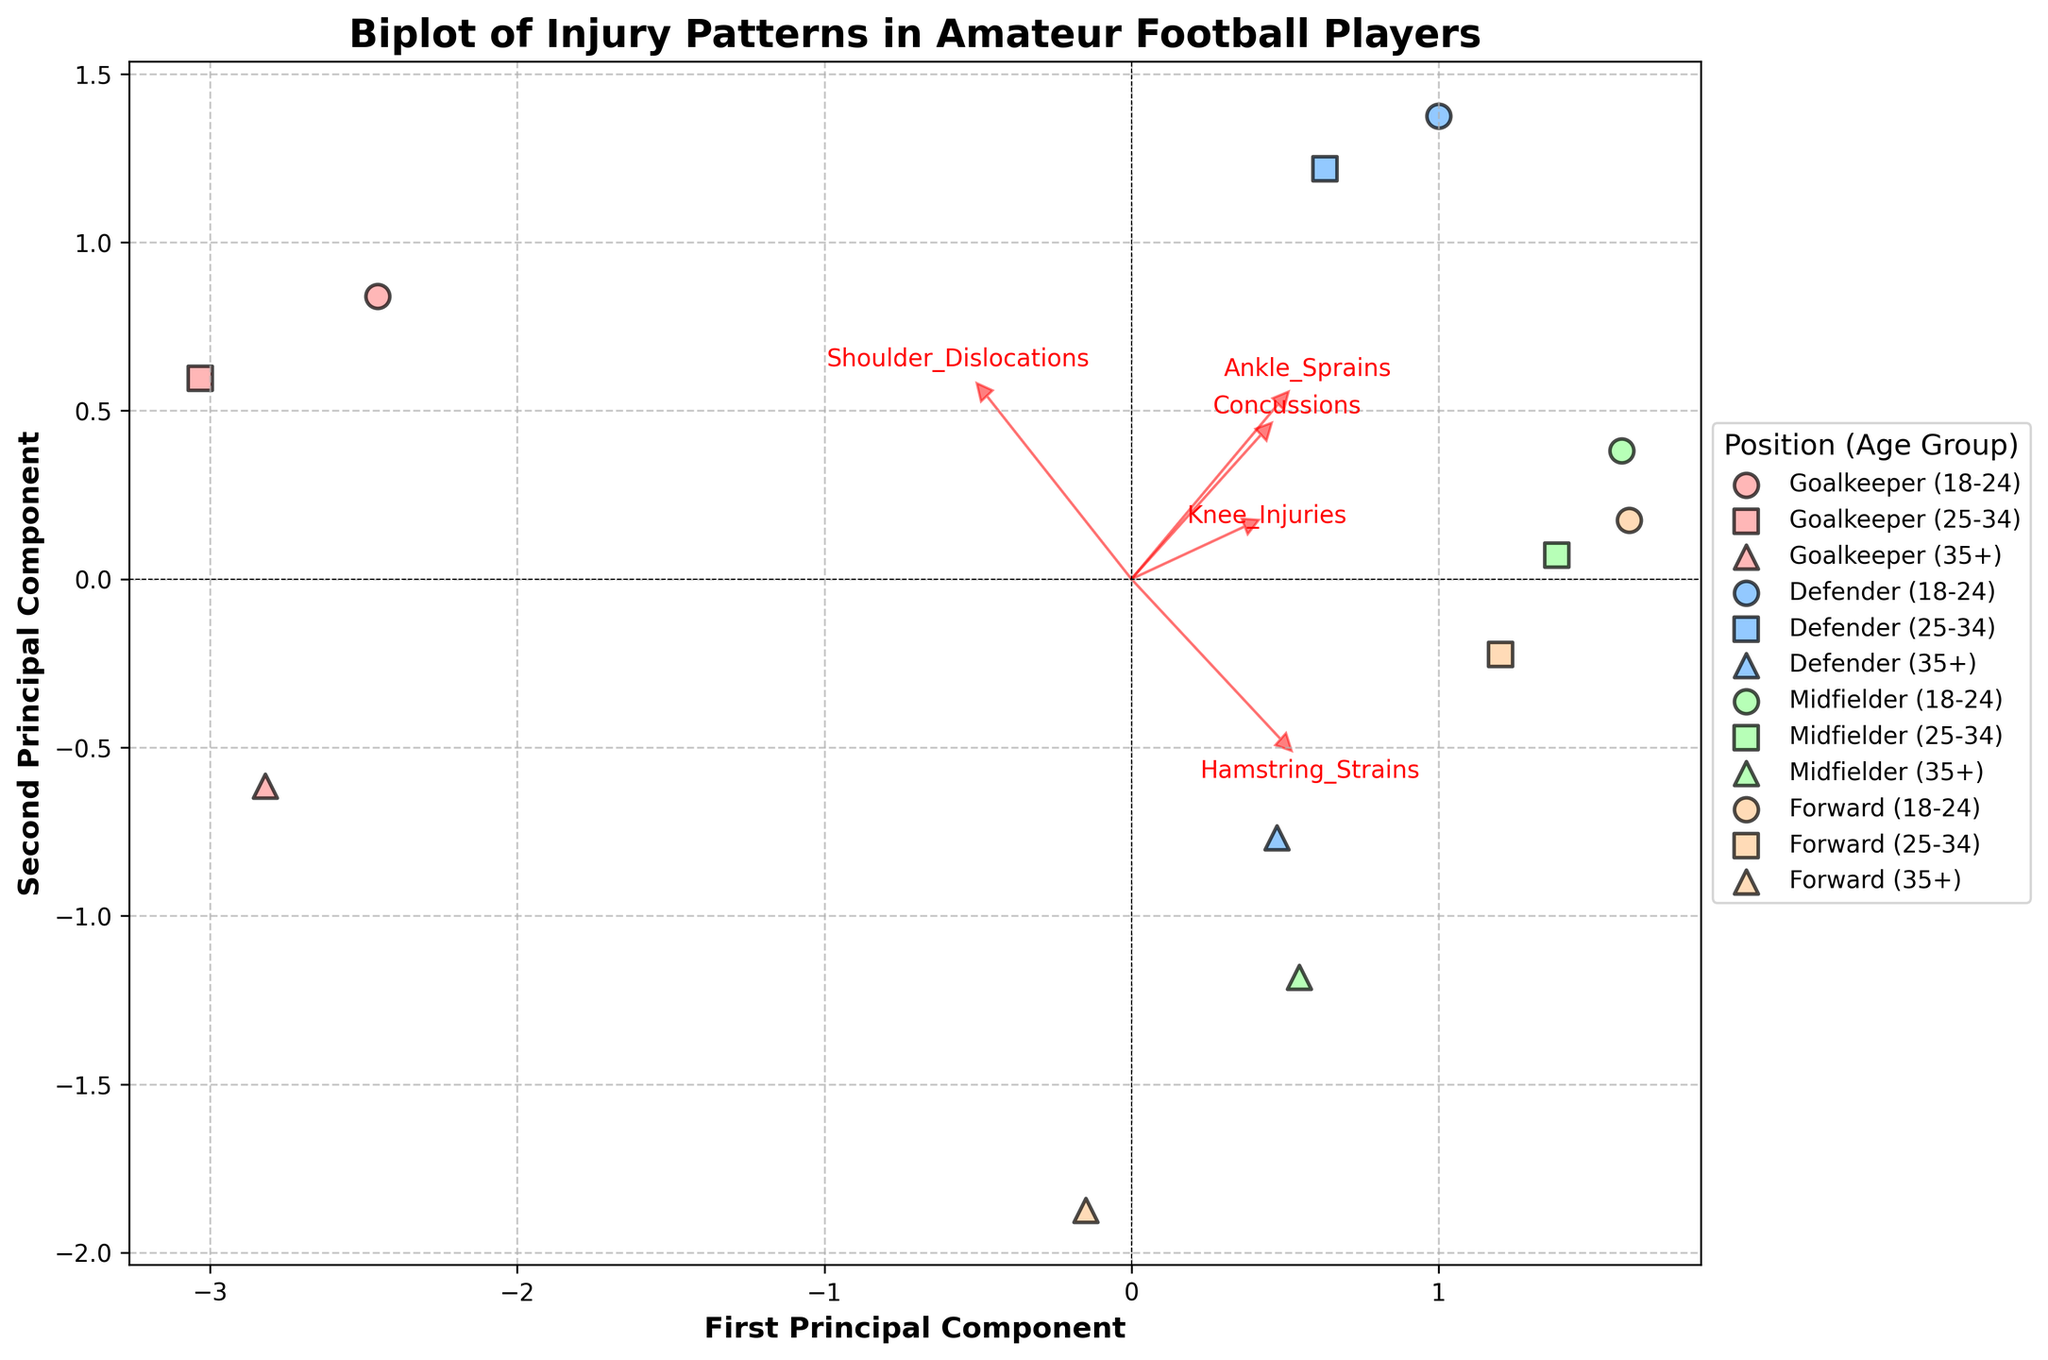What's the title of the plot? The title is found at the top of the plot and provides a quick summary of what the plot is about. It labels the figure and gives context to the viewer.
Answer: Biplot of Injury Patterns in Amateur Football Players What do the x and y axes represent? The x and y axes are labeled on the plot. They represent the first and second principal components, respectively, which are combinations of the standardized original features. These axes help to visualize the variance in the data.
Answer: First Principal Component and Second Principal Component How are the positions and age groups differentiated on the plot? Positions and age groups are separated by different colors and markers. Positions like Goalkeeper, Defender, Midfielder, and Forward each have distinct colors, while age groups like 18-24, 25-34, and 35+ have specific markers. This helps in identifying different categories visually.
Answer: By different colors and markers Which injury type is most strongly associated with the first principal component? One should look at the feature vectors (arrows) and their direction along the first principal component axis. The length and orientation of these arrows indicate the strength and association of each feature with the principal components.
Answer: Ankle Sprains Which positional group seems to have the highest association with Shoulder Dislocations? To find this, look for the position group data points that are closest along the direction of the arrow labeled "Shoulder_Dislocations." This can be inferred from the direction of the arrow and the clustering of points.
Answer: Goalkeepers Compare the clustering of Midfielders aged 25-34 and Defenders aged 35+. Which group shows a higher association with Knee Injuries? Look at the locations of the specific markers for each group (Midfielders aged 25-34 and Defenders aged 35+). Then assess their proximity to the arrow indicating Knee Injuries. This involves understanding the general distribution of the data points.
Answer: Midfielders aged 25-34 Which age group of Forwards tend to have similar injury patterns? Identify the markers for different age groups within the Forward category. By observing the clustering and overlap among these markers, you can infer which age groups have similar injury patterns.
Answer: 25-34 and 35+ Between Goalkeepers aged 18-24 and 35+, which group is more associated with Concussions? Examine the proximity of the data points for each specified group to the arrow labeled "Concussions." The closer the points are to that arrow, the higher the association.
Answer: Goalkeepers aged 18-24 What can you infer about the relationship between Ankle Sprains and Hamstring Strains based on the feature vectors? The arrows representing Ankle Sprains and Hamstring Strains indicate their relationship by their direction and length. If the arrows point in similar directions, there is likely a positive correlation between these features.
Answer: Positive correlation 